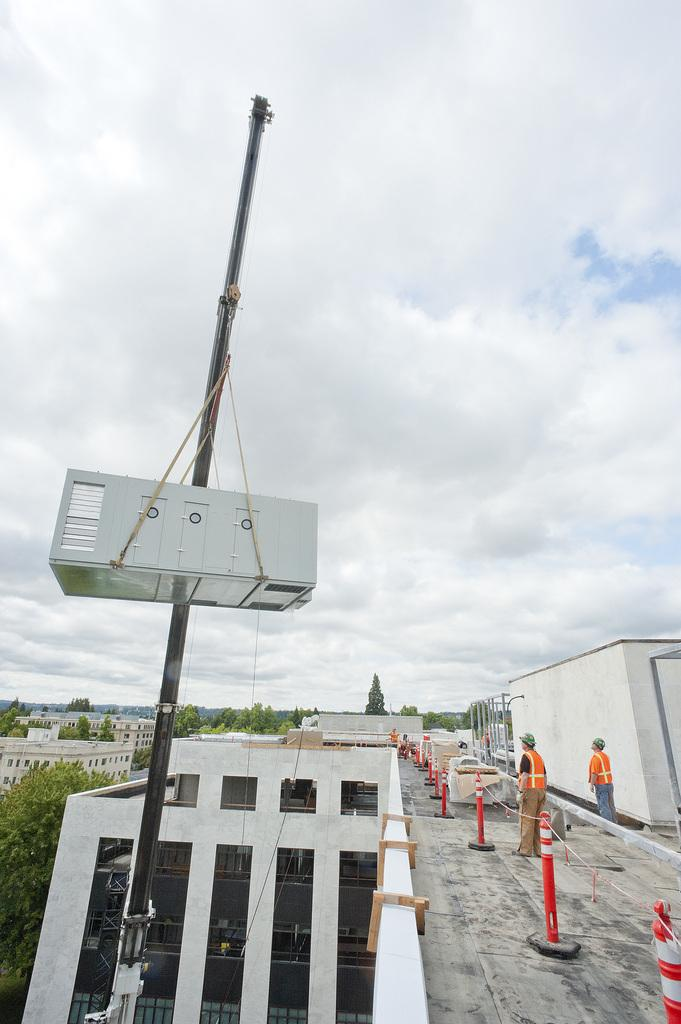Who are the two people on the right side of the image? The facts do not provide information about the identities of the two people. What is the object hanging on the left side of the image? The facts do not specify the nature of the object hanging on the left side of the image. What can be seen in the background of the image? In the background of the image, there are buildings, trees, and clouds in the sky. What type of voice can be heard coming from the object hanging on the left side of the image? There is no voice present in the image, as it only features two people and an unspecified object hanging on the left side. 